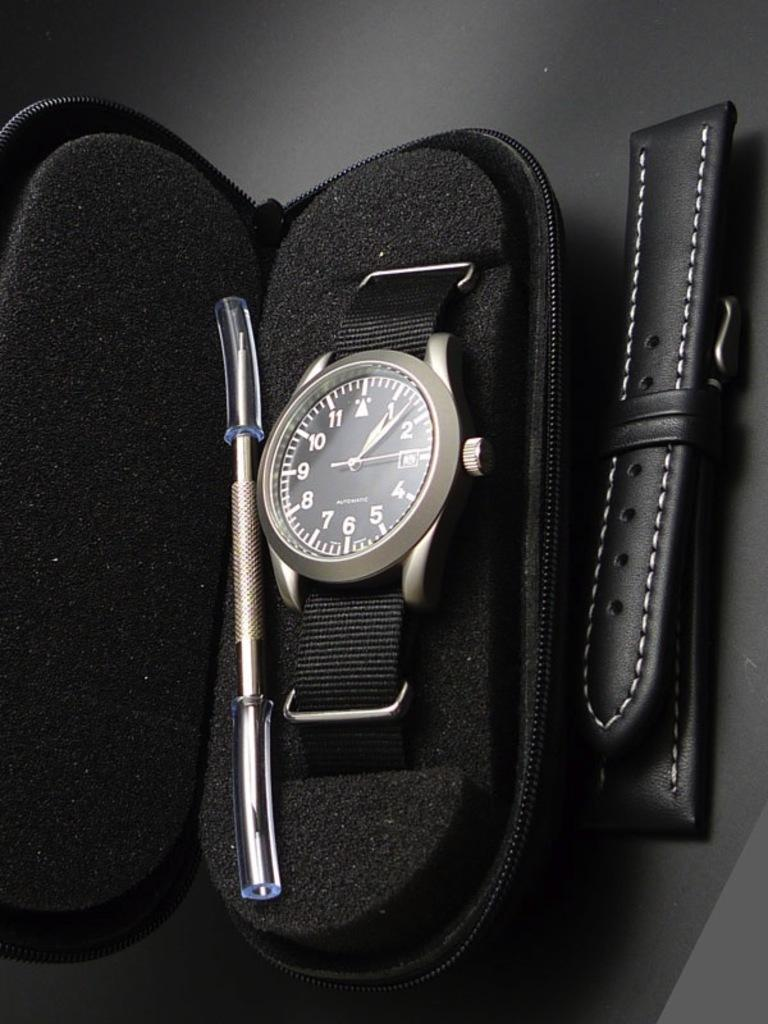Provide a one-sentence caption for the provided image. A black watch in a case that has the hour hand on the "1" and the second hand on the "3". 